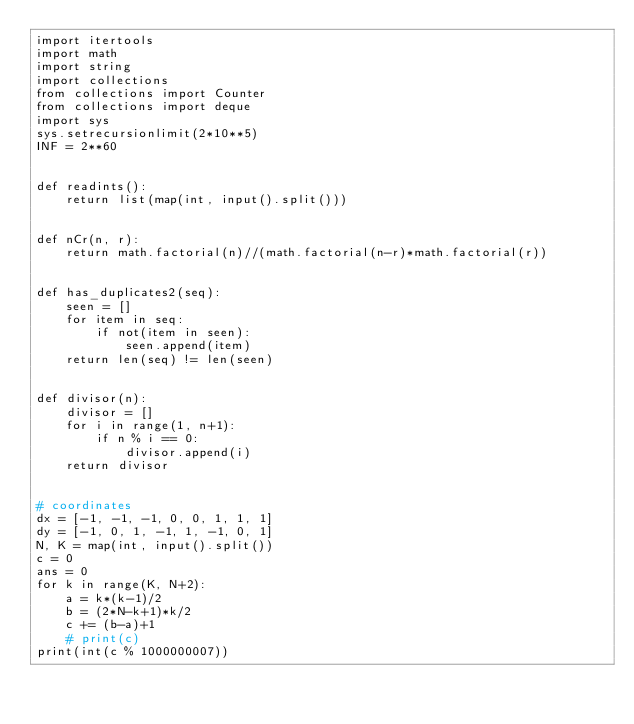Convert code to text. <code><loc_0><loc_0><loc_500><loc_500><_Python_>import itertools
import math
import string
import collections
from collections import Counter
from collections import deque
import sys
sys.setrecursionlimit(2*10**5)
INF = 2**60


def readints():
    return list(map(int, input().split()))


def nCr(n, r):
    return math.factorial(n)//(math.factorial(n-r)*math.factorial(r))


def has_duplicates2(seq):
    seen = []
    for item in seq:
        if not(item in seen):
            seen.append(item)
    return len(seq) != len(seen)


def divisor(n):
    divisor = []
    for i in range(1, n+1):
        if n % i == 0:
            divisor.append(i)
    return divisor


# coordinates
dx = [-1, -1, -1, 0, 0, 1, 1, 1]
dy = [-1, 0, 1, -1, 1, -1, 0, 1]
N, K = map(int, input().split())
c = 0
ans = 0
for k in range(K, N+2):
    a = k*(k-1)/2
    b = (2*N-k+1)*k/2
    c += (b-a)+1
    # print(c)
print(int(c % 1000000007))
</code> 